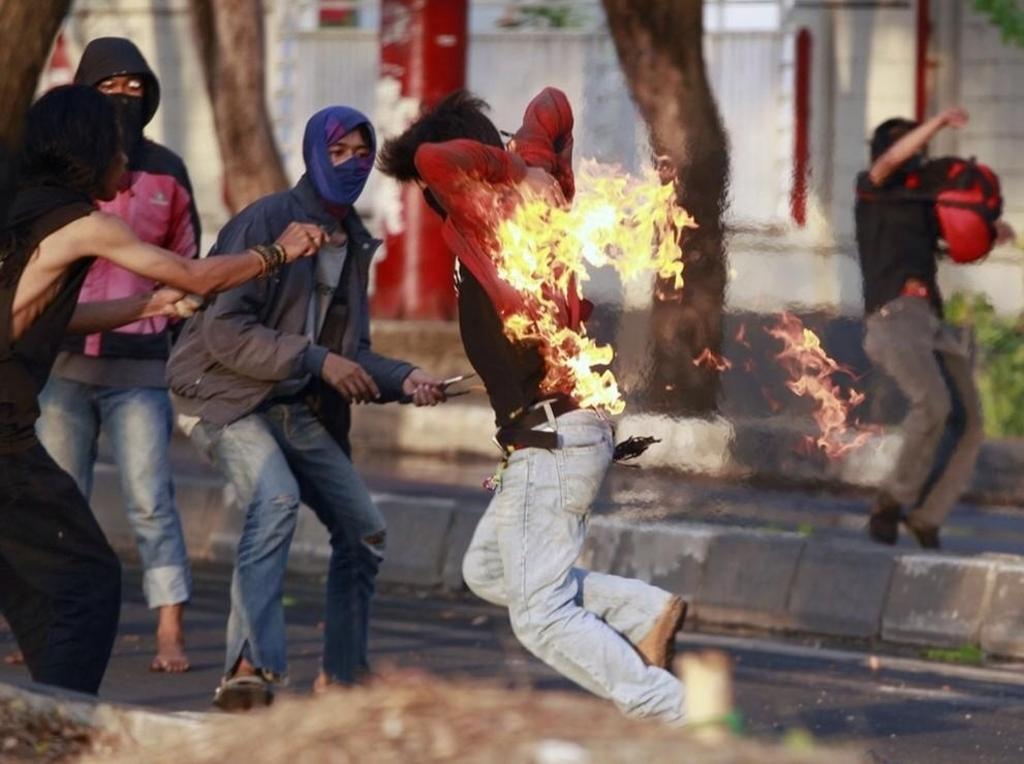Could you give a brief overview of what you see in this image? In the center of the image there is a man and we can see a fire on his shirt. In the background there are people and trees. At the bottom there is a road. 